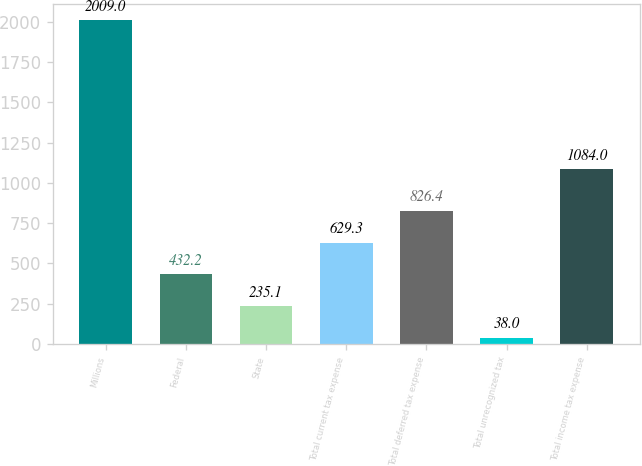Convert chart. <chart><loc_0><loc_0><loc_500><loc_500><bar_chart><fcel>Millions<fcel>Federal<fcel>State<fcel>Total current tax expense<fcel>Total deferred tax expense<fcel>Total unrecognized tax<fcel>Total income tax expense<nl><fcel>2009<fcel>432.2<fcel>235.1<fcel>629.3<fcel>826.4<fcel>38<fcel>1084<nl></chart> 